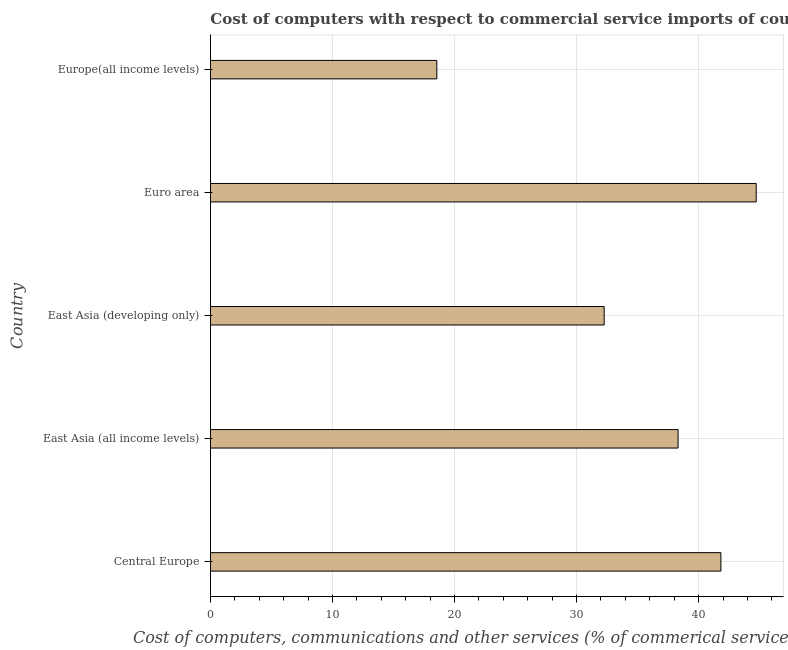What is the title of the graph?
Provide a short and direct response. Cost of computers with respect to commercial service imports of countries in 2006. What is the label or title of the X-axis?
Offer a very short reply. Cost of computers, communications and other services (% of commerical service exports). What is the label or title of the Y-axis?
Your response must be concise. Country. What is the  computer and other services in Euro area?
Provide a succinct answer. 44.72. Across all countries, what is the maximum  computer and other services?
Keep it short and to the point. 44.72. Across all countries, what is the minimum  computer and other services?
Give a very brief answer. 18.55. In which country was the  computer and other services minimum?
Provide a succinct answer. Europe(all income levels). What is the sum of the cost of communications?
Your response must be concise. 175.67. What is the difference between the  computer and other services in Central Europe and East Asia (all income levels)?
Keep it short and to the point. 3.51. What is the average cost of communications per country?
Offer a very short reply. 35.13. What is the median  computer and other services?
Your answer should be compact. 38.32. What is the ratio of the  computer and other services in Central Europe to that in Euro area?
Offer a very short reply. 0.94. What is the difference between the highest and the second highest  computer and other services?
Offer a very short reply. 2.89. What is the difference between the highest and the lowest cost of communications?
Your answer should be very brief. 26.17. How many bars are there?
Your answer should be compact. 5. Are all the bars in the graph horizontal?
Offer a very short reply. Yes. Are the values on the major ticks of X-axis written in scientific E-notation?
Make the answer very short. No. What is the Cost of computers, communications and other services (% of commerical service exports) of Central Europe?
Offer a terse response. 41.83. What is the Cost of computers, communications and other services (% of commerical service exports) of East Asia (all income levels)?
Provide a succinct answer. 38.32. What is the Cost of computers, communications and other services (% of commerical service exports) in East Asia (developing only)?
Your response must be concise. 32.26. What is the Cost of computers, communications and other services (% of commerical service exports) in Euro area?
Keep it short and to the point. 44.72. What is the Cost of computers, communications and other services (% of commerical service exports) of Europe(all income levels)?
Your answer should be very brief. 18.55. What is the difference between the Cost of computers, communications and other services (% of commerical service exports) in Central Europe and East Asia (all income levels)?
Offer a very short reply. 3.51. What is the difference between the Cost of computers, communications and other services (% of commerical service exports) in Central Europe and East Asia (developing only)?
Offer a very short reply. 9.57. What is the difference between the Cost of computers, communications and other services (% of commerical service exports) in Central Europe and Euro area?
Offer a terse response. -2.89. What is the difference between the Cost of computers, communications and other services (% of commerical service exports) in Central Europe and Europe(all income levels)?
Provide a short and direct response. 23.28. What is the difference between the Cost of computers, communications and other services (% of commerical service exports) in East Asia (all income levels) and East Asia (developing only)?
Ensure brevity in your answer.  6.06. What is the difference between the Cost of computers, communications and other services (% of commerical service exports) in East Asia (all income levels) and Euro area?
Offer a very short reply. -6.4. What is the difference between the Cost of computers, communications and other services (% of commerical service exports) in East Asia (all income levels) and Europe(all income levels)?
Offer a very short reply. 19.77. What is the difference between the Cost of computers, communications and other services (% of commerical service exports) in East Asia (developing only) and Euro area?
Ensure brevity in your answer.  -12.46. What is the difference between the Cost of computers, communications and other services (% of commerical service exports) in East Asia (developing only) and Europe(all income levels)?
Your response must be concise. 13.71. What is the difference between the Cost of computers, communications and other services (% of commerical service exports) in Euro area and Europe(all income levels)?
Keep it short and to the point. 26.17. What is the ratio of the Cost of computers, communications and other services (% of commerical service exports) in Central Europe to that in East Asia (all income levels)?
Offer a terse response. 1.09. What is the ratio of the Cost of computers, communications and other services (% of commerical service exports) in Central Europe to that in East Asia (developing only)?
Offer a terse response. 1.3. What is the ratio of the Cost of computers, communications and other services (% of commerical service exports) in Central Europe to that in Euro area?
Provide a succinct answer. 0.94. What is the ratio of the Cost of computers, communications and other services (% of commerical service exports) in Central Europe to that in Europe(all income levels)?
Provide a short and direct response. 2.25. What is the ratio of the Cost of computers, communications and other services (% of commerical service exports) in East Asia (all income levels) to that in East Asia (developing only)?
Offer a terse response. 1.19. What is the ratio of the Cost of computers, communications and other services (% of commerical service exports) in East Asia (all income levels) to that in Euro area?
Provide a succinct answer. 0.86. What is the ratio of the Cost of computers, communications and other services (% of commerical service exports) in East Asia (all income levels) to that in Europe(all income levels)?
Keep it short and to the point. 2.07. What is the ratio of the Cost of computers, communications and other services (% of commerical service exports) in East Asia (developing only) to that in Euro area?
Offer a very short reply. 0.72. What is the ratio of the Cost of computers, communications and other services (% of commerical service exports) in East Asia (developing only) to that in Europe(all income levels)?
Offer a very short reply. 1.74. What is the ratio of the Cost of computers, communications and other services (% of commerical service exports) in Euro area to that in Europe(all income levels)?
Your answer should be compact. 2.41. 